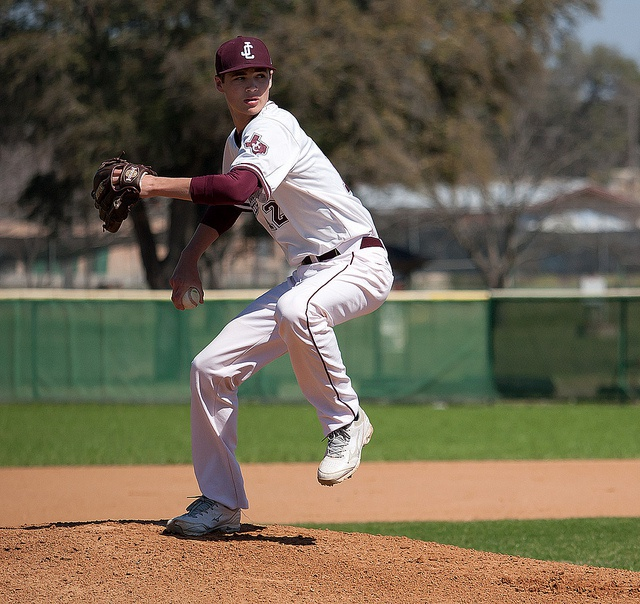Describe the objects in this image and their specific colors. I can see people in black, white, and gray tones, baseball glove in black, maroon, and gray tones, and sports ball in black, gray, and maroon tones in this image. 